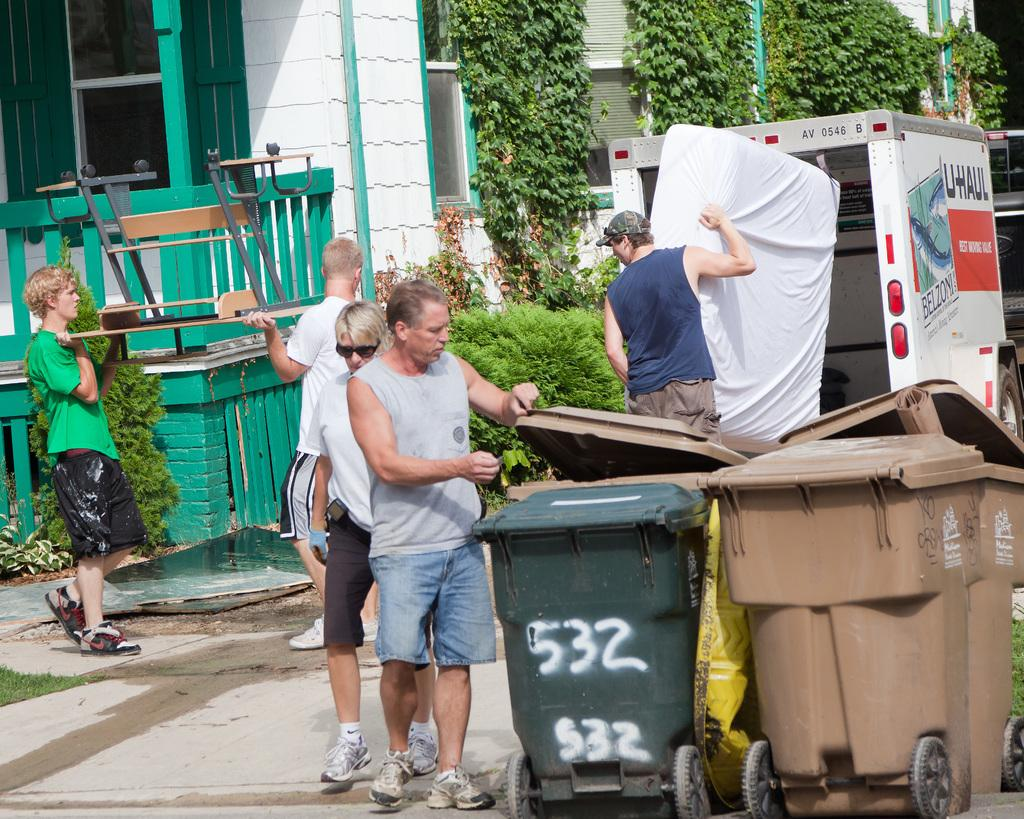<image>
Render a clear and concise summary of the photo. Several men in the street with a trash can that has the numbers 532 on the side. 